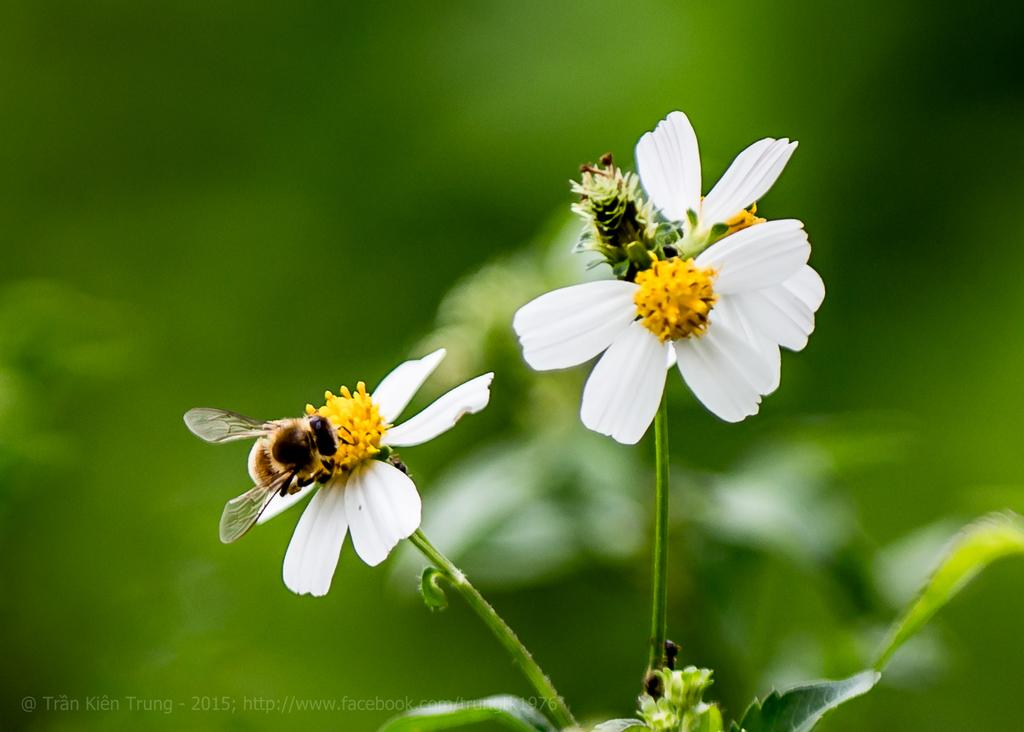What type of plants can be seen in the image? There are flowers in the image. What insects are present in the image? Honey bees are present in the image. What parts of the flowers are visible in the image? Leaves and stems are present in the image. How would you describe the background of the image? The background of the image is blurred and green. Is there any additional information or branding on the image? Yes, there is a watermark on the image. Can you tell me how many coasts are visible in the image? There are no coasts visible in the image; it features flowers and honey bees. What type of lift is being used by the honey bees in the image? Honey bees do not use lifts; they fly using their wings. 